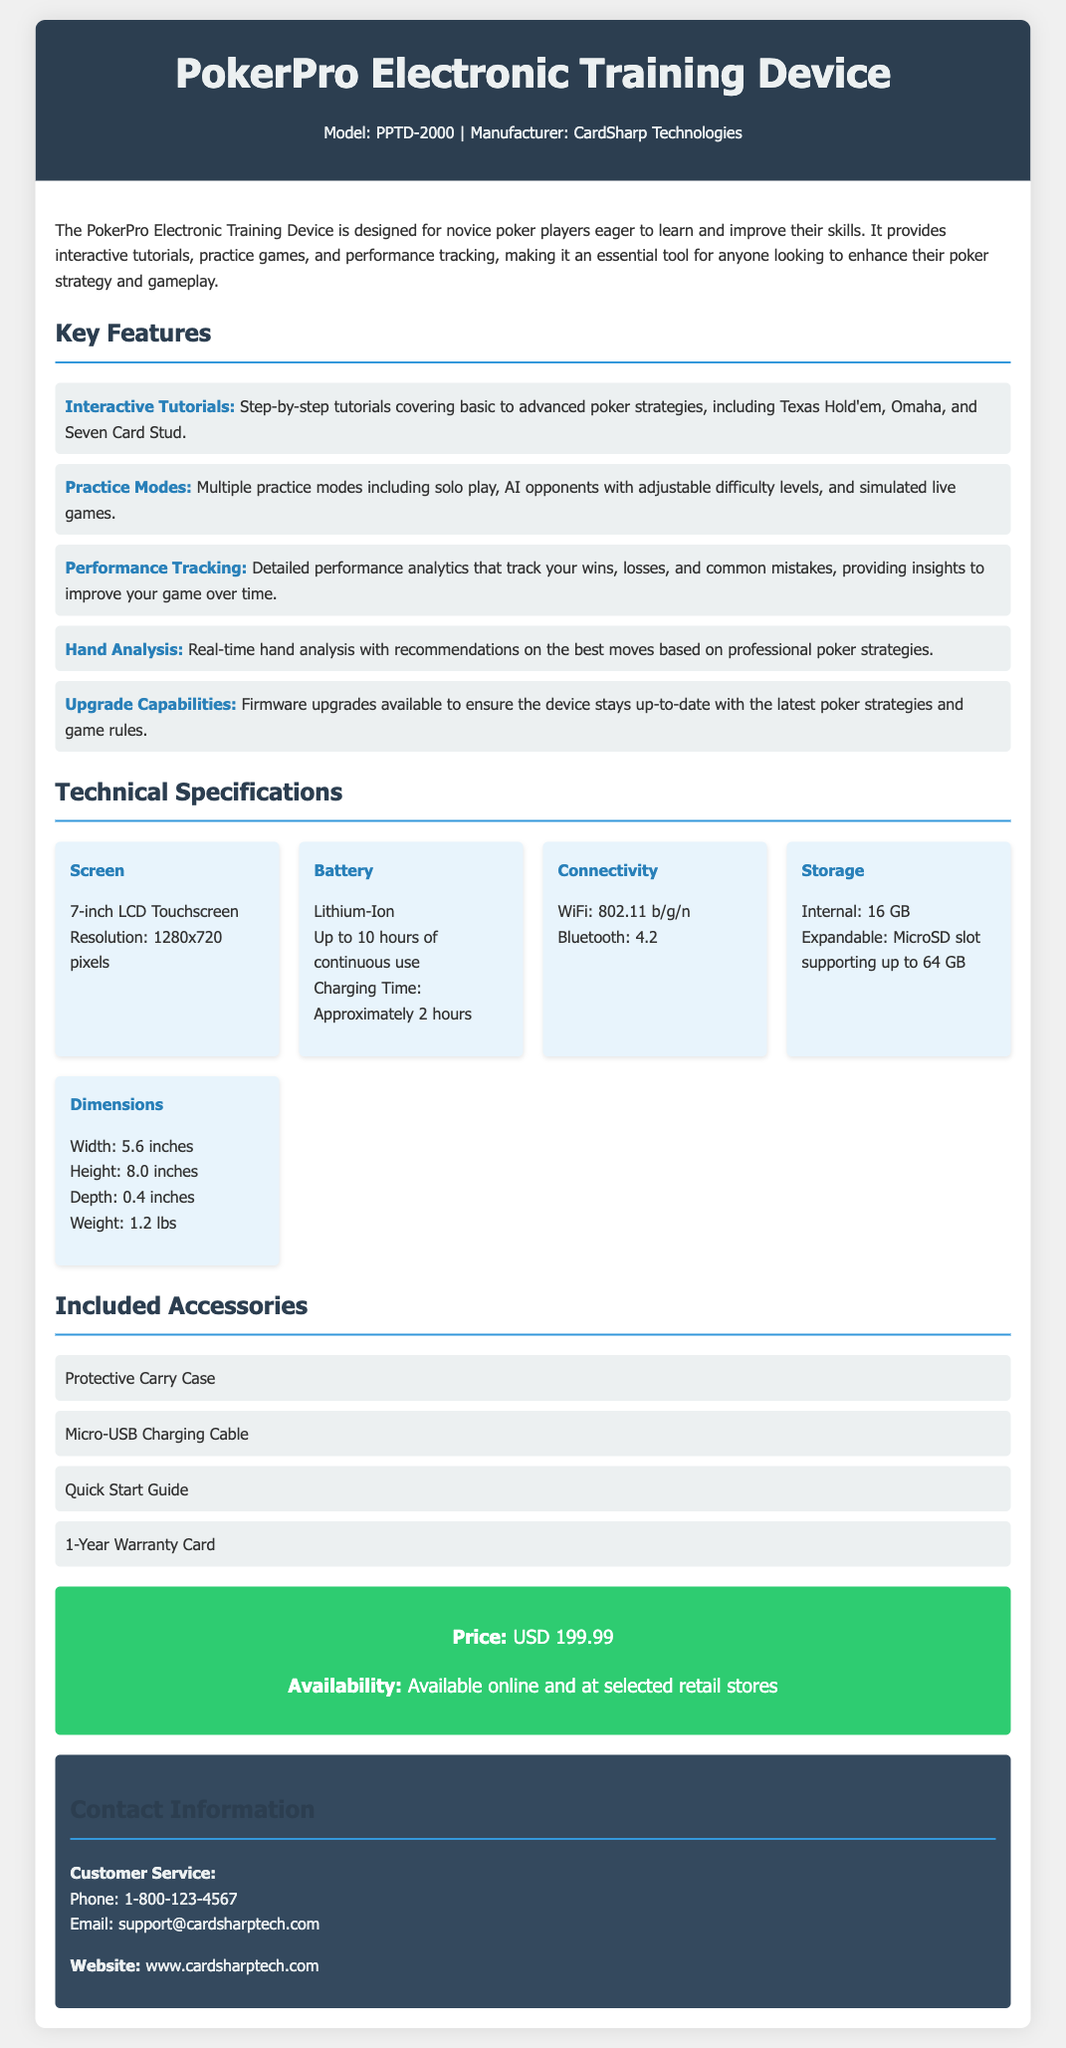What is the model of the device? The model of the device is specified in the header as PPTD-2000.
Answer: PPTD-2000 Who is the manufacturer? The manufacturer's name is mentioned in the header of the document.
Answer: CardSharp Technologies What type of display does the device have? The technical specifications include details about the screen type, which is a 7-inch LCD Touchscreen.
Answer: 7-inch LCD Touchscreen How long is the battery life? The battery specifications indicate the device can last up to 10 hours of continuous use.
Answer: 10 hours What is the storage capacity of the device? The storage specifications state that the internal storage is 16 GB, with an expandable option.
Answer: 16 GB What is included with the device? The included accessories section lists four items that come with the device.
Answer: Protective Carry Case, Micro-USB Charging Cable, Quick Start Guide, 1-Year Warranty Card What is the price of the device? The price is mentioned in the price availability section of the document.
Answer: USD 199.99 What types of games can be practiced on the device? The key features section describes various practice modes that include specific poker games.
Answer: Texas Hold'em, Omaha, Seven Card Stud What analytics does the device provide? The performance tracking feature states it provides detailed performance analytics tracking wins and losses.
Answer: Performance analytics What is the charging time of the battery? The battery specifications outline how long it takes to charge the device fully.
Answer: Approximately 2 hours 